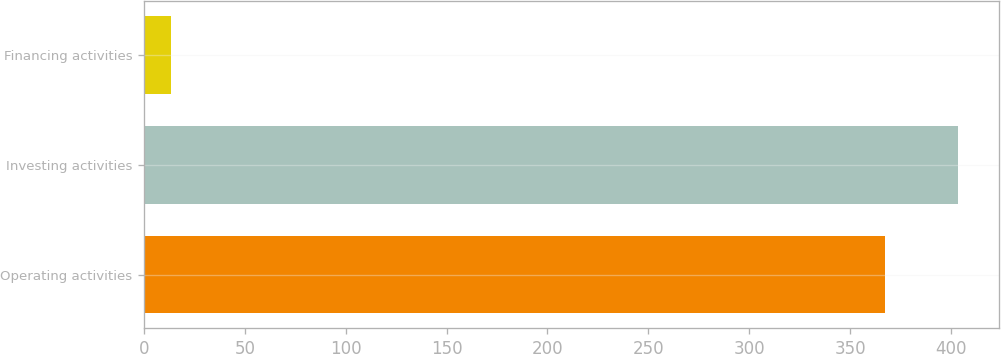<chart> <loc_0><loc_0><loc_500><loc_500><bar_chart><fcel>Operating activities<fcel>Investing activities<fcel>Financing activities<nl><fcel>367.5<fcel>403.56<fcel>13.6<nl></chart> 